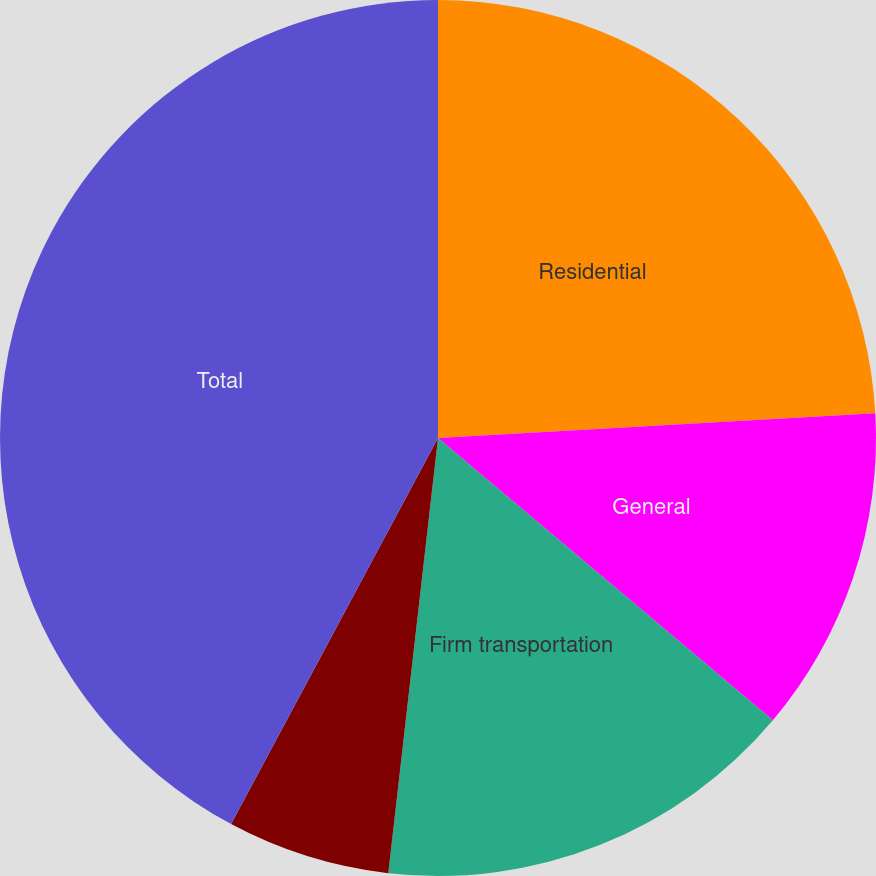<chart> <loc_0><loc_0><loc_500><loc_500><pie_chart><fcel>Residential<fcel>General<fcel>Firm transportation<fcel>Interruptible sales<fcel>Total<nl><fcel>24.1%<fcel>12.05%<fcel>15.66%<fcel>6.02%<fcel>42.17%<nl></chart> 